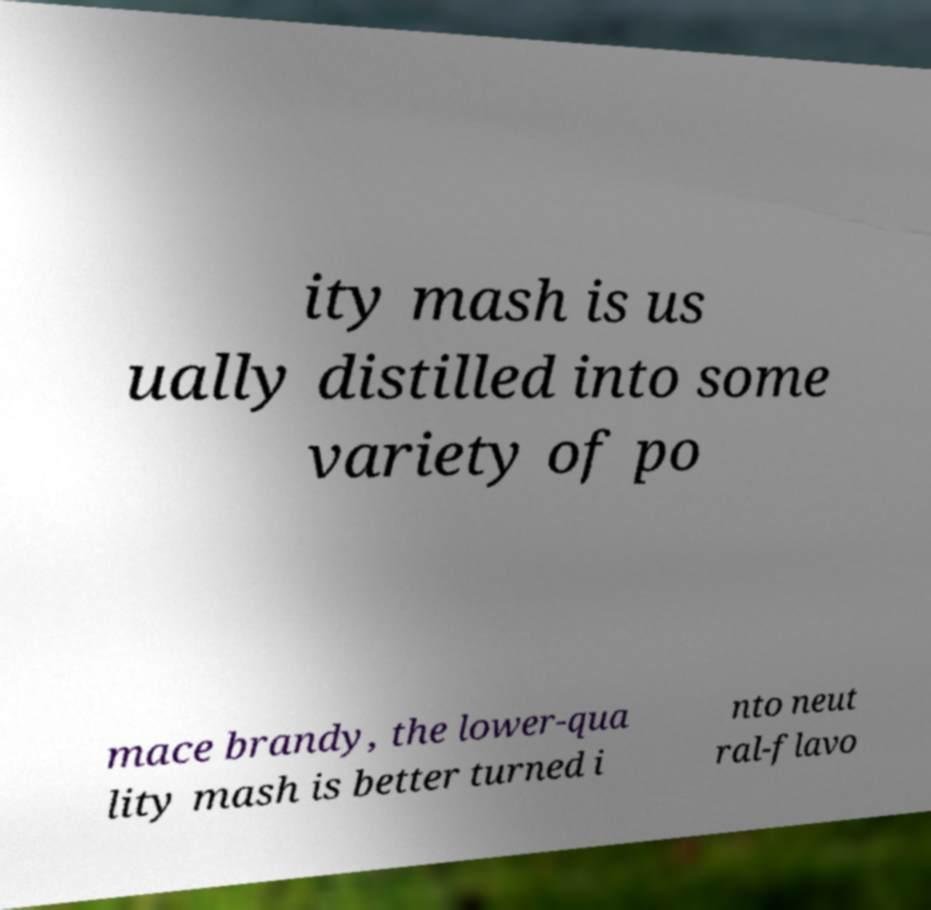Could you extract and type out the text from this image? ity mash is us ually distilled into some variety of po mace brandy, the lower-qua lity mash is better turned i nto neut ral-flavo 